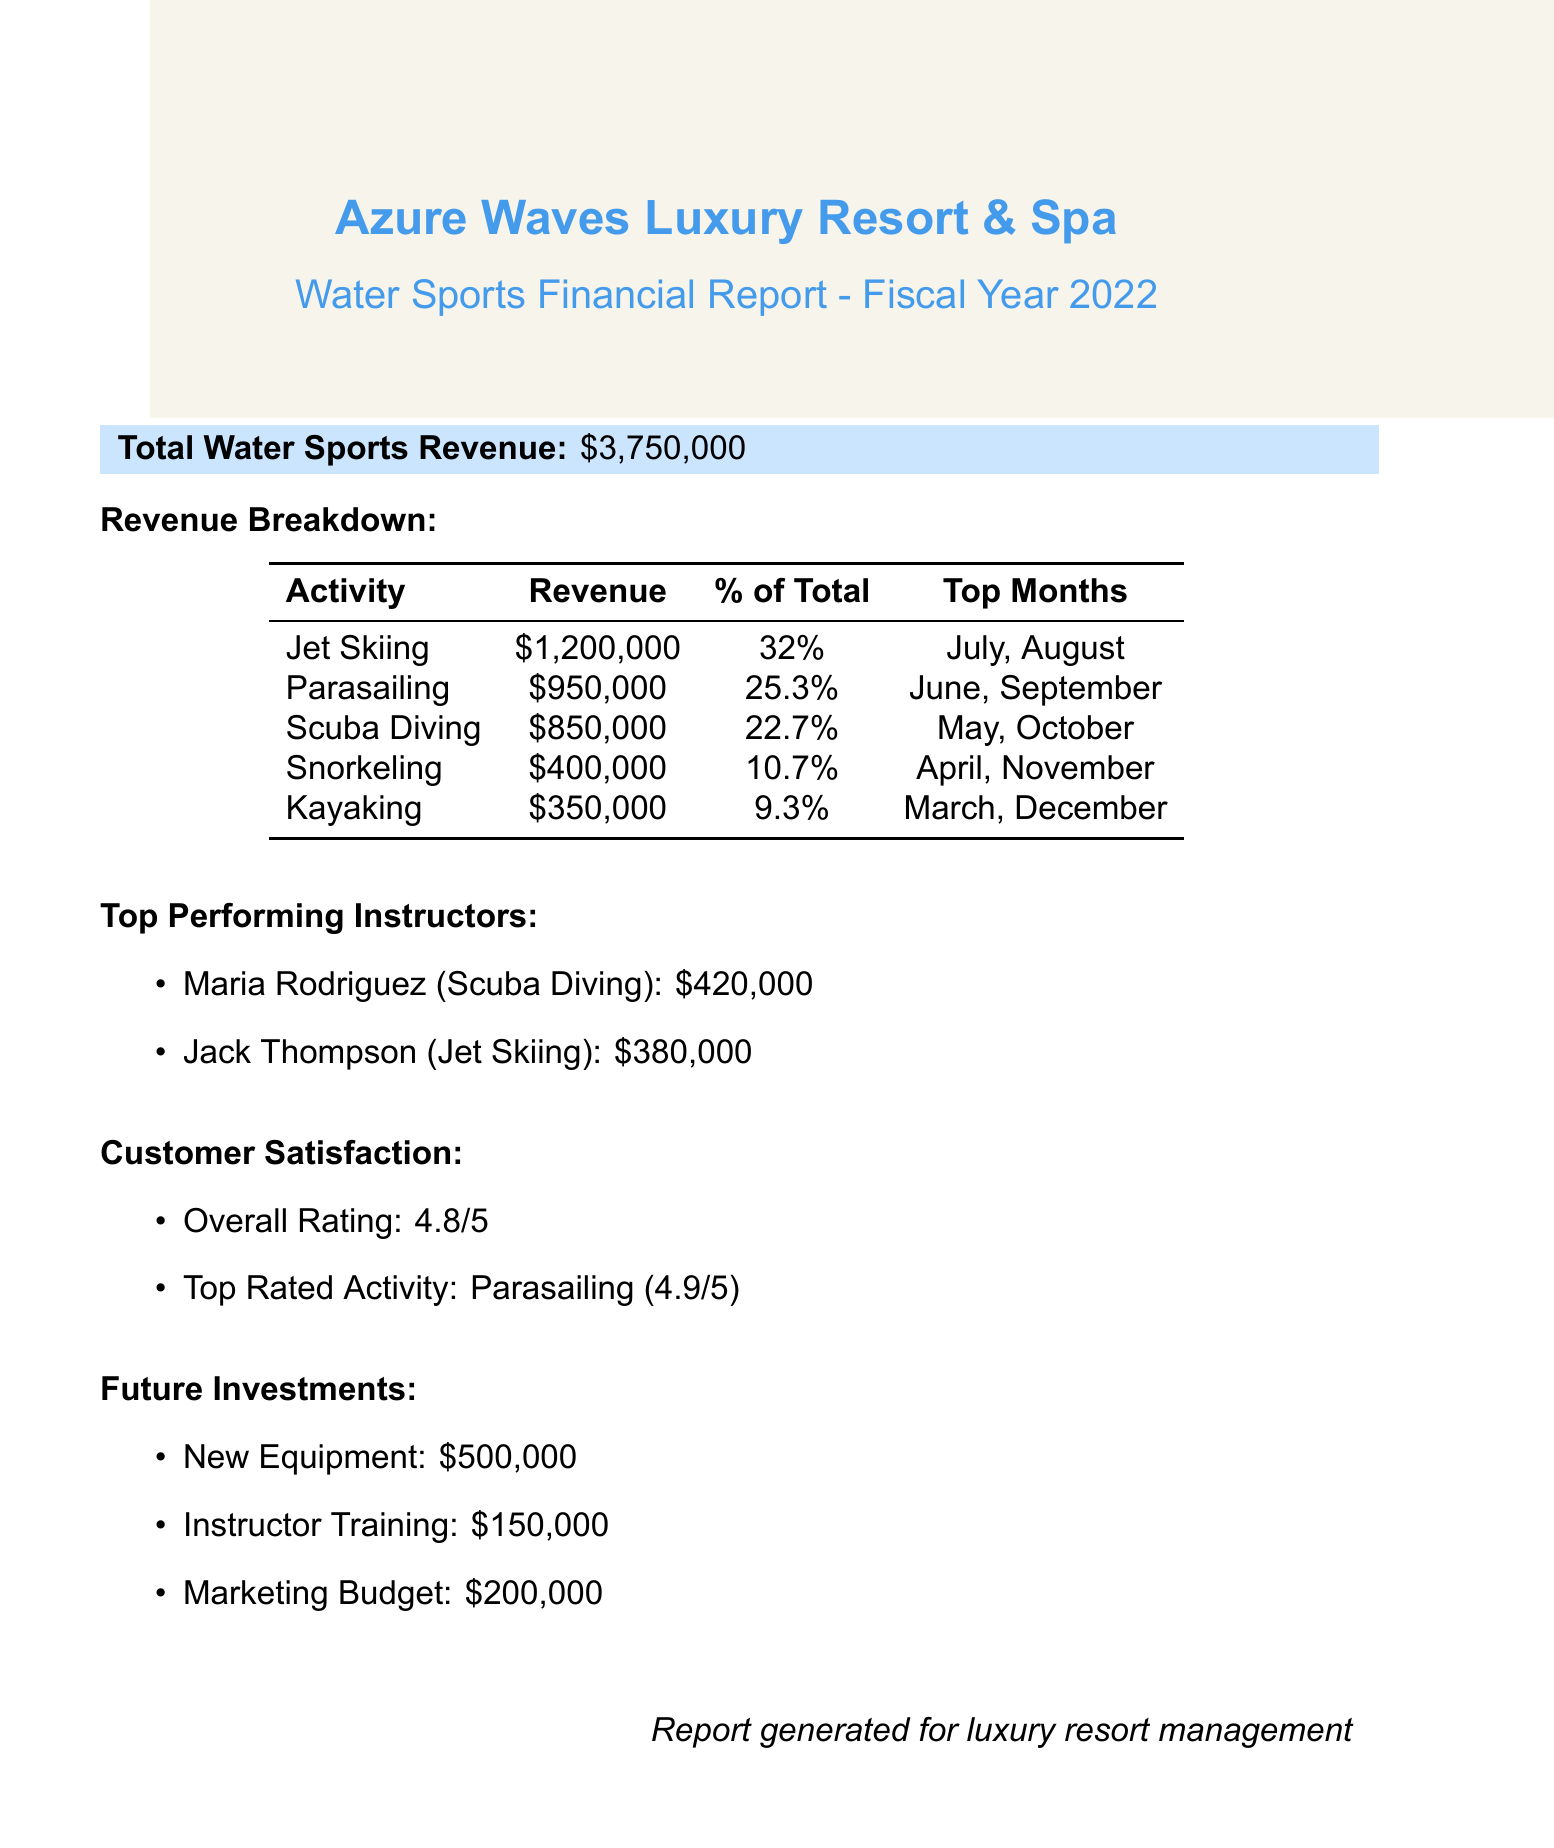What is the total water sports revenue? The total revenue is explicitly stated in the document as $3,750,000.
Answer: $3,750,000 Which activity generated the most revenue? The revenue breakdown shows that Jet Skiing generated the highest revenue at $1,200,000.
Answer: Jet Skiing What percentage of total revenue did Parasailing account for? The breakdown lists that Parasailing accounted for 25.3% of the total revenue.
Answer: 25.3% Who was the top-performing instructor for Scuba Diving? The document identifies Maria Rodriguez as the top-performing instructor for Scuba Diving, generating $420,000.
Answer: Maria Rodriguez In which months did Jet Skiing show the highest activity? According to the document, the top months for Jet Skiing are July and August.
Answer: July, August What is the overall customer satisfaction rating? The overall rating for customer satisfaction is mentioned as 4.8 out of 5 in the document.
Answer: 4.8 How much is allocated for new equipment in future investments? The document states that $500,000 is allocated for new equipment.
Answer: $500,000 What is the top-rated activity based on customer feedback? The document indicates that the top-rated activity is Parasailing, with a rating of 4.9.
Answer: Parasailing How much revenue did Scuba Diving generate? The breakdown specifies that Scuba Diving generated $850,000 in revenue.
Answer: $850,000 